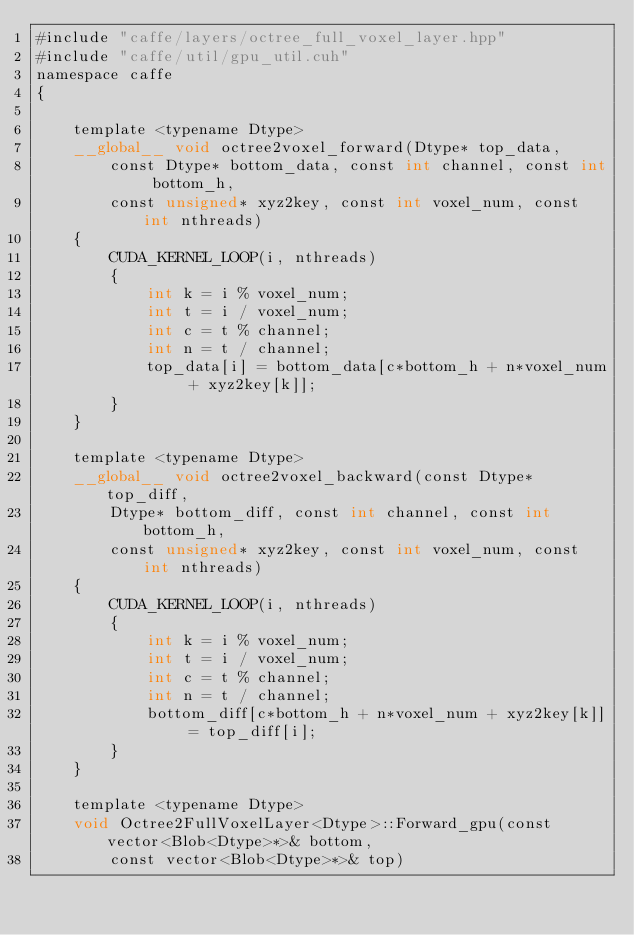<code> <loc_0><loc_0><loc_500><loc_500><_Cuda_>#include "caffe/layers/octree_full_voxel_layer.hpp"
#include "caffe/util/gpu_util.cuh"
namespace caffe
{

	template <typename Dtype>
	__global__ void octree2voxel_forward(Dtype* top_data,
		const Dtype* bottom_data, const int channel, const int bottom_h,
		const unsigned* xyz2key, const int voxel_num, const int nthreads)
	{
		CUDA_KERNEL_LOOP(i, nthreads)
		{
			int k = i % voxel_num;
			int t = i / voxel_num;
			int c = t % channel;
			int n = t / channel;
			top_data[i] = bottom_data[c*bottom_h + n*voxel_num + xyz2key[k]];
		}
	}

	template <typename Dtype>
	__global__ void octree2voxel_backward(const Dtype* top_diff,
		Dtype* bottom_diff, const int channel, const int bottom_h,
		const unsigned* xyz2key, const int voxel_num, const int nthreads)
	{
		CUDA_KERNEL_LOOP(i, nthreads)
		{
			int k = i % voxel_num;
			int t = i / voxel_num;
			int c = t % channel;
			int n = t / channel;
			bottom_diff[c*bottom_h + n*voxel_num + xyz2key[k]] = top_diff[i];
		}
	}

	template <typename Dtype>
	void Octree2FullVoxelLayer<Dtype>::Forward_gpu(const vector<Blob<Dtype>*>& bottom,
		const vector<Blob<Dtype>*>& top)</code> 